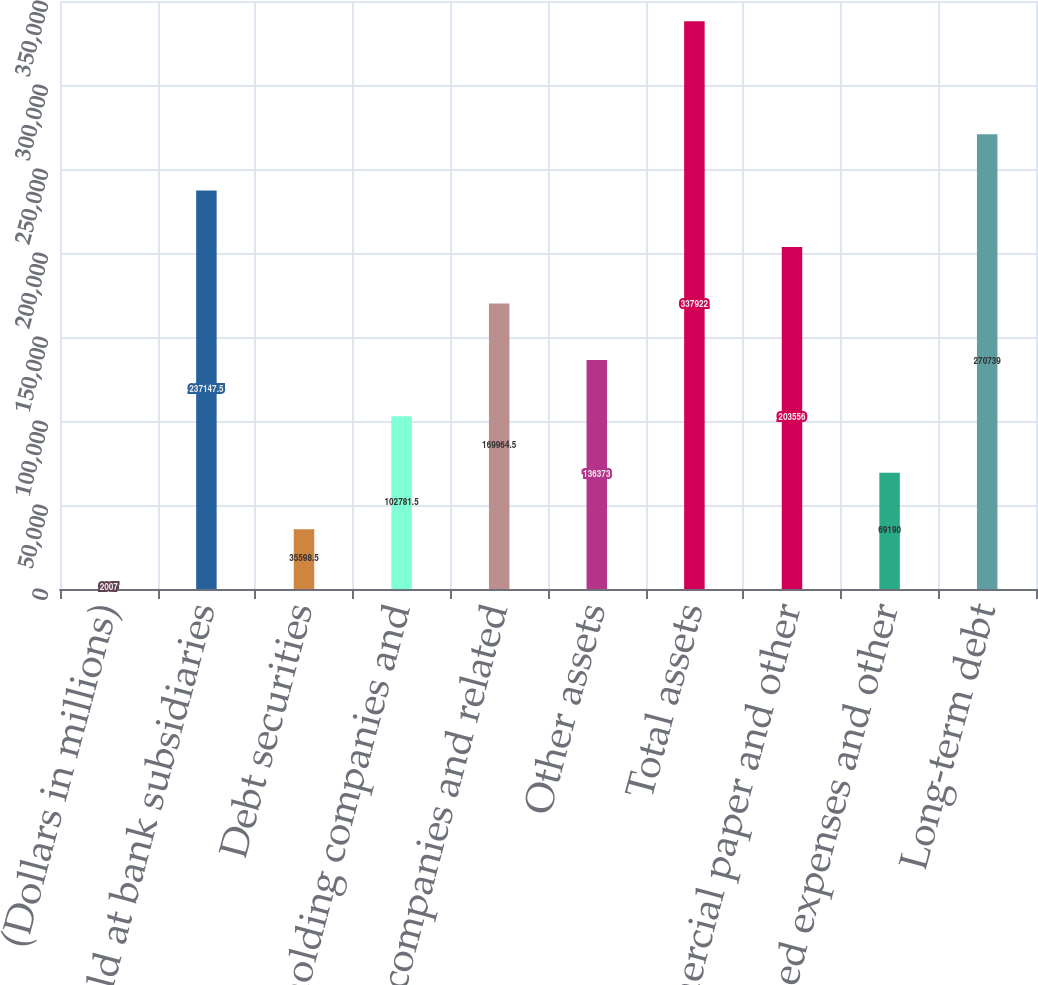Convert chart to OTSL. <chart><loc_0><loc_0><loc_500><loc_500><bar_chart><fcel>(Dollars in millions)<fcel>Cash held at bank subsidiaries<fcel>Debt securities<fcel>Bank holding companies and<fcel>Nonbank companies and related<fcel>Other assets<fcel>Total assets<fcel>Commercial paper and other<fcel>Accrued expenses and other<fcel>Long-term debt<nl><fcel>2007<fcel>237148<fcel>35598.5<fcel>102782<fcel>169964<fcel>136373<fcel>337922<fcel>203556<fcel>69190<fcel>270739<nl></chart> 